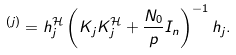Convert formula to latex. <formula><loc_0><loc_0><loc_500><loc_500>^ { ( j ) } = h _ { j } ^ { \mathcal { H } } \left ( K _ { j } K _ { j } ^ { \mathcal { H } } + \frac { N _ { 0 } } { p } I _ { n } \right ) ^ { - 1 } h _ { j } .</formula> 